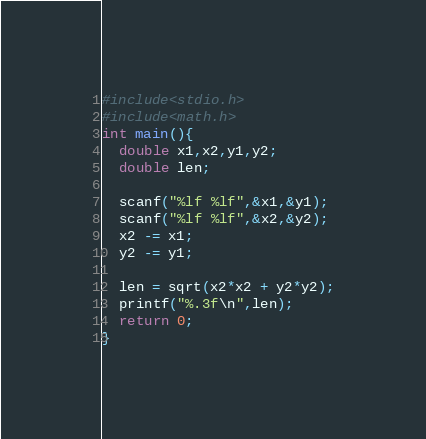<code> <loc_0><loc_0><loc_500><loc_500><_C_>#include<stdio.h>
#include<math.h>
int main(){
  double x1,x2,y1,y2;
  double len;

  scanf("%lf %lf",&x1,&y1);
  scanf("%lf %lf",&x2,&y2);
  x2 -= x1;
  y2 -= y1;

  len = sqrt(x2*x2 + y2*y2);
  printf("%.3f\n",len);
  return 0;
}

</code> 